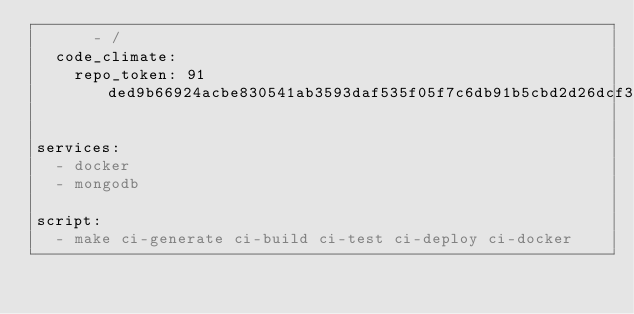<code> <loc_0><loc_0><loc_500><loc_500><_YAML_>      - /
  code_climate:
    repo_token: 91ded9b66924acbe830541ab3593daf535f05f7c6db91b5cbd2d26dcf37da0b8

services:
  - docker
  - mongodb

script:
  - make ci-generate ci-build ci-test ci-deploy ci-docker
</code> 